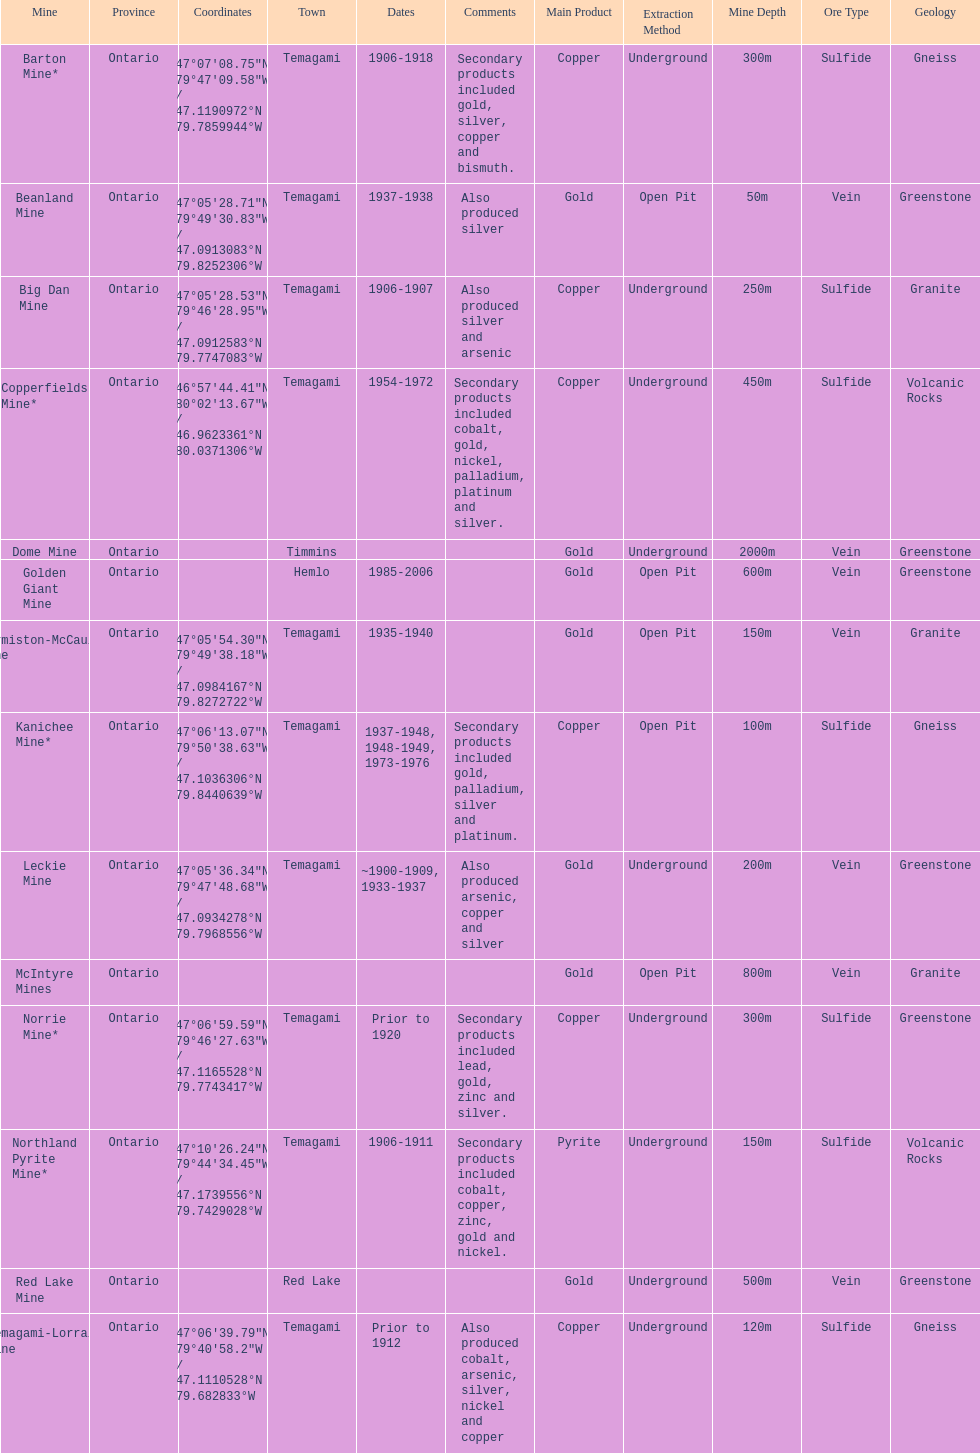What mine is in the town of timmins? Dome Mine. Could you parse the entire table? {'header': ['Mine', 'Province', 'Coordinates', 'Town', 'Dates', 'Comments', 'Main Product', 'Extraction Method', 'Mine Depth', 'Ore Type', 'Geology'], 'rows': [['Barton Mine*', 'Ontario', '47°07′08.75″N 79°47′09.58″W\ufeff / \ufeff47.1190972°N 79.7859944°W', 'Temagami', '1906-1918', 'Secondary products included gold, silver, copper and bismuth.', 'Copper', 'Underground', '300m', 'Sulfide', 'Gneiss'], ['Beanland Mine', 'Ontario', '47°05′28.71″N 79°49′30.83″W\ufeff / \ufeff47.0913083°N 79.8252306°W', 'Temagami', '1937-1938', 'Also produced silver', 'Gold', 'Open Pit', '50m', 'Vein', 'Greenstone'], ['Big Dan Mine', 'Ontario', '47°05′28.53″N 79°46′28.95″W\ufeff / \ufeff47.0912583°N 79.7747083°W', 'Temagami', '1906-1907', 'Also produced silver and arsenic', 'Copper', 'Underground', '250m', 'Sulfide', 'Granite'], ['Copperfields Mine*', 'Ontario', '46°57′44.41″N 80°02′13.67″W\ufeff / \ufeff46.9623361°N 80.0371306°W', 'Temagami', '1954-1972', 'Secondary products included cobalt, gold, nickel, palladium, platinum and silver.', 'Copper', 'Underground', '450m', 'Sulfide', 'Volcanic Rocks'], ['Dome Mine', 'Ontario', '', 'Timmins', '', '', 'Gold', 'Underground', '2000m', 'Vein', 'Greenstone'], ['Golden Giant Mine', 'Ontario', '', 'Hemlo', '1985-2006', '', 'Gold', 'Open Pit', '600m', 'Vein', 'Greenstone'], ['Hermiston-McCauley Mine', 'Ontario', '47°05′54.30″N 79°49′38.18″W\ufeff / \ufeff47.0984167°N 79.8272722°W', 'Temagami', '1935-1940', '', 'Gold', 'Open Pit', '150m', 'Vein', 'Granite'], ['Kanichee Mine*', 'Ontario', '47°06′13.07″N 79°50′38.63″W\ufeff / \ufeff47.1036306°N 79.8440639°W', 'Temagami', '1937-1948, 1948-1949, 1973-1976', 'Secondary products included gold, palladium, silver and platinum.', 'Copper', 'Open Pit', '100m', 'Sulfide', 'Gneiss'], ['Leckie Mine', 'Ontario', '47°05′36.34″N 79°47′48.68″W\ufeff / \ufeff47.0934278°N 79.7968556°W', 'Temagami', '~1900-1909, 1933-1937', 'Also produced arsenic, copper and silver', 'Gold', 'Underground', '200m', 'Vein', 'Greenstone'], ['McIntyre Mines', 'Ontario', '', '', '', '', 'Gold', 'Open Pit', '800m', 'Vein', 'Granite'], ['Norrie Mine*', 'Ontario', '47°06′59.59″N 79°46′27.63″W\ufeff / \ufeff47.1165528°N 79.7743417°W', 'Temagami', 'Prior to 1920', 'Secondary products included lead, gold, zinc and silver.', 'Copper', 'Underground', '300m', 'Sulfide', 'Greenstone'], ['Northland Pyrite Mine*', 'Ontario', '47°10′26.24″N 79°44′34.45″W\ufeff / \ufeff47.1739556°N 79.7429028°W', 'Temagami', '1906-1911', 'Secondary products included cobalt, copper, zinc, gold and nickel.', 'Pyrite', 'Underground', '150m', 'Sulfide', 'Volcanic Rocks'], ['Red Lake Mine', 'Ontario', '', 'Red Lake', '', '', 'Gold', 'Underground', '500m', 'Vein', 'Greenstone'], ['Temagami-Lorrain Mine', 'Ontario', '47°06′39.79″N 79°40′58.2″W\ufeff / \ufeff47.1110528°N 79.682833°W', 'Temagami', 'Prior to 1912', 'Also produced cobalt, arsenic, silver, nickel and copper', 'Copper', 'Underground', '120m', 'Sulfide', 'Gneiss']]} 